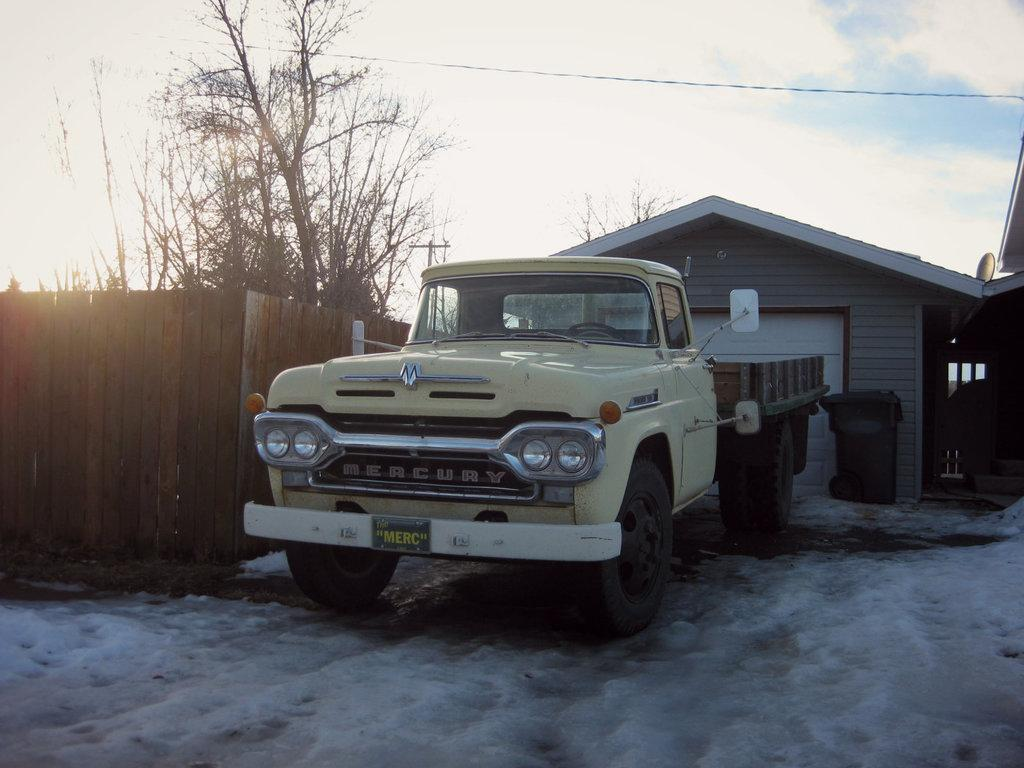<image>
Present a compact description of the photo's key features. An old Mercury truck sits in the snow outside of a garage. 